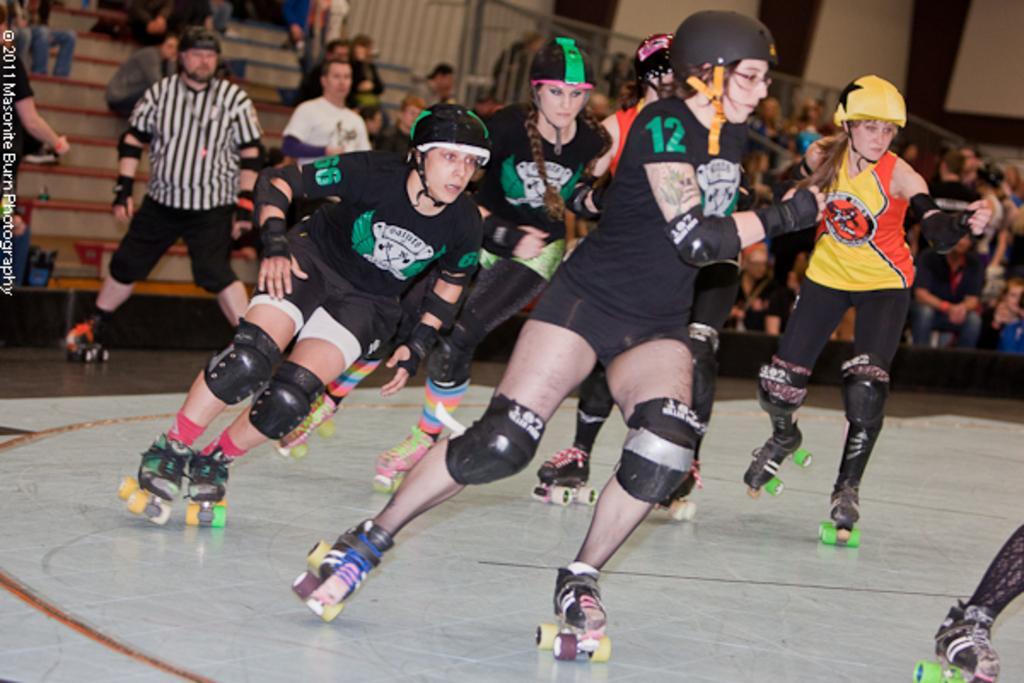Can you describe this image briefly? In the foreground of the picture there are women skating. In the center there is a referee skating. In the background there are audience sitting on benches. The background is blurred. 